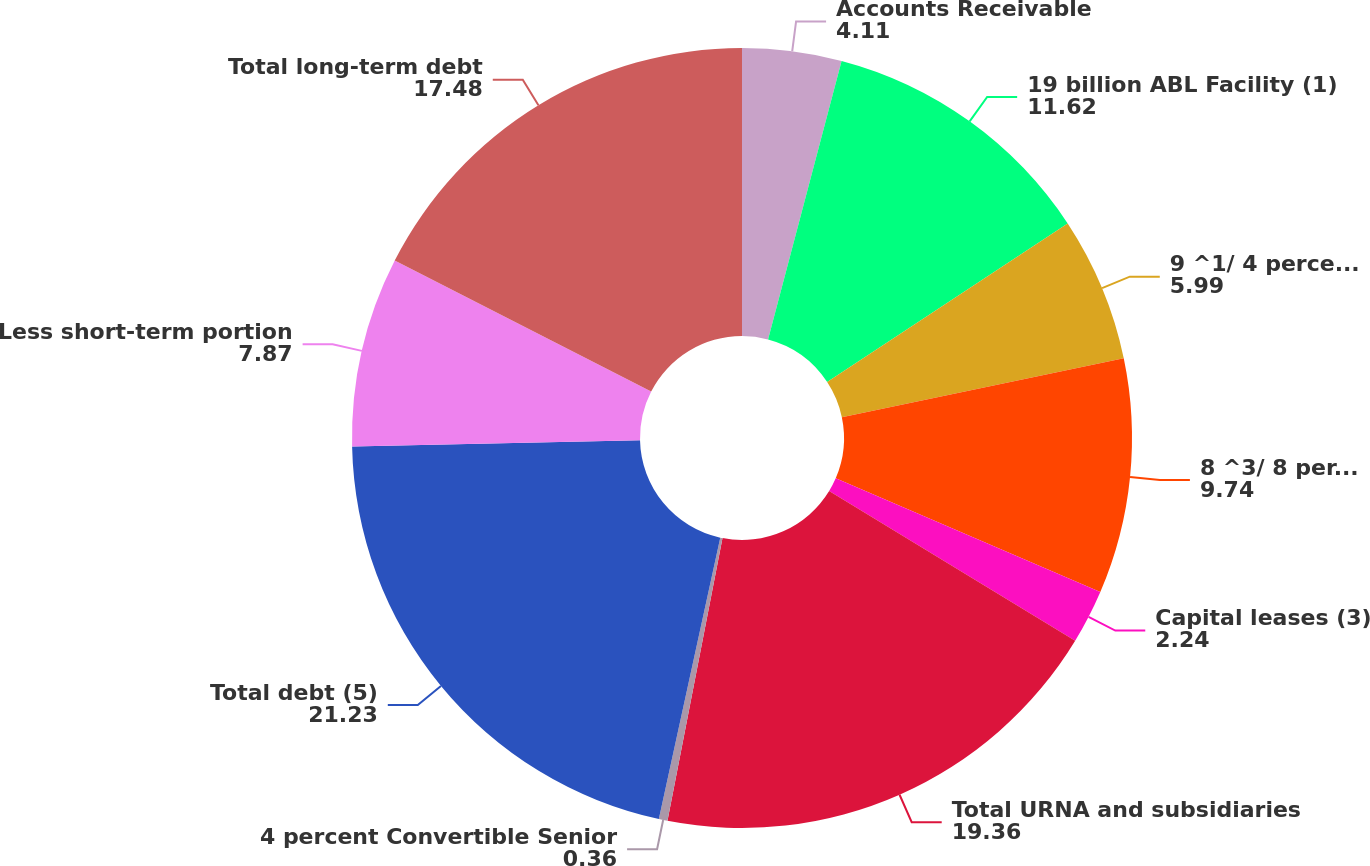Convert chart. <chart><loc_0><loc_0><loc_500><loc_500><pie_chart><fcel>Accounts Receivable<fcel>19 billion ABL Facility (1)<fcel>9 ^1/ 4 percent Senior Notes<fcel>8 ^3/ 8 percent Senior<fcel>Capital leases (3)<fcel>Total URNA and subsidiaries<fcel>4 percent Convertible Senior<fcel>Total debt (5)<fcel>Less short-term portion<fcel>Total long-term debt<nl><fcel>4.11%<fcel>11.62%<fcel>5.99%<fcel>9.74%<fcel>2.24%<fcel>19.36%<fcel>0.36%<fcel>21.23%<fcel>7.87%<fcel>17.48%<nl></chart> 